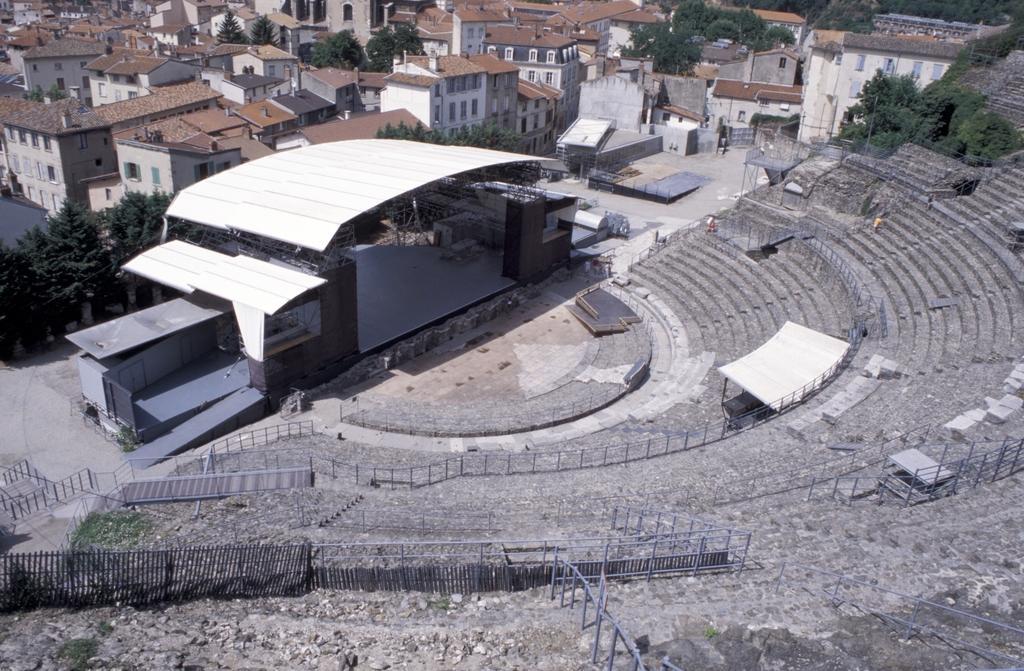Can you describe this image briefly? In this picture we can see an amphitheater on the path and iron fences. Behind the amphitheater there are trees and buildings. 